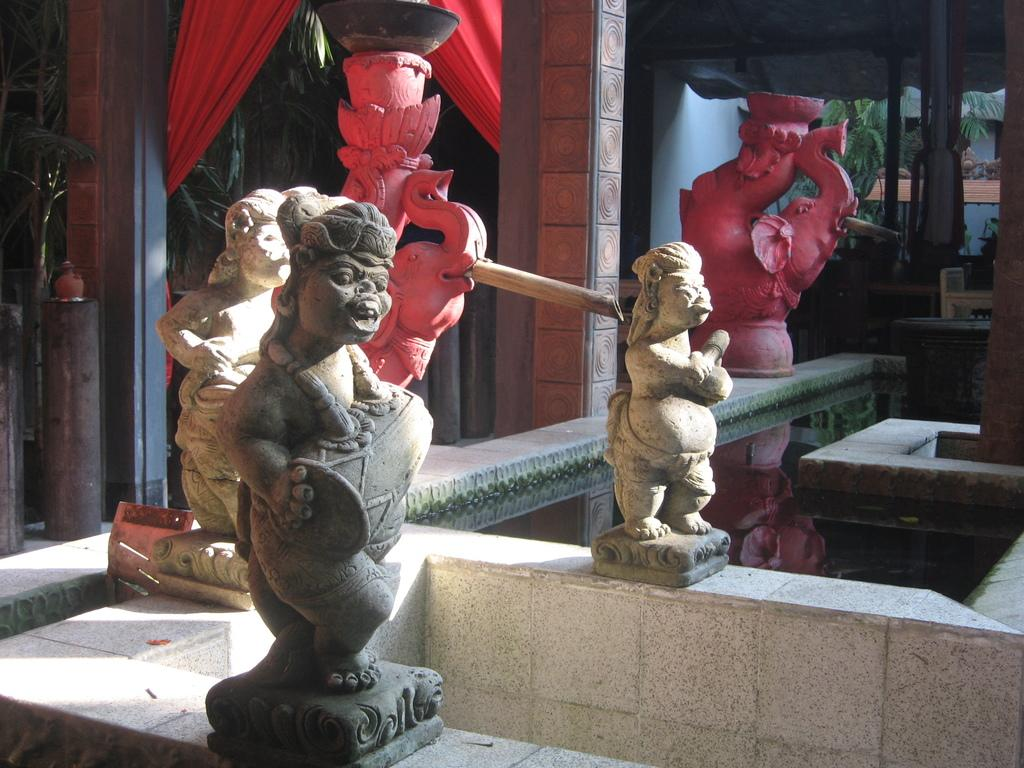What type of art is present in the image? There are sculptures in the image. What colors are the sculptures? The sculptures are in grey and pink colors. What architectural elements can be seen in the image? There are pillars in the image. What type of window treatment is present in the image? There are two red color curtains in the image. What can be seen in the background of the image? There are trees in the background of the image. How many cows are visible in the image? There are no cows present in the image. What type of shop can be seen in the background of the image? There is no shop visible in the image; it features sculptures, pillars, curtains, and trees. 